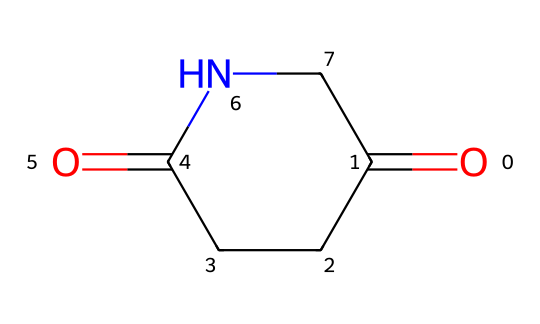What is the total number of carbon atoms in glutarimide? The SMILES representation indicates the presence of three carbon atoms in the cyclic part (C1CCC) and two carbonyl carbon atoms (O=C), totaling five carbon atoms.
Answer: five How many nitrogen atoms are present in the structure of glutarimide? By analyzing the SMILES notation, there is one nitrogen atom (N) in the ring structure of glutarimide.
Answer: one What type of functional group is present in glutarimide? The structure contains both carbonyl groups (C=O) and an amine (N), categorizing it as an imide. An imide is characterized by two carbonyl groups bonded to a nitrogen atom.
Answer: imide What is the ring size of the glutarimide structure? The molecular structure forms a five-membered ring as indicated by the C1CCC(=O)NC1, which includes three carbon atoms and one nitrogen in a ring.
Answer: five-membered How many double bonds are present in glutarimide? The structure contains two double bonds—one each from the two carbonyl groups (O=C) attached to the nitrogen and carbon atoms.
Answer: two What role does the nitrogen atom play in the glutarimide structure? The nitrogen atom functions as a point of connection for the two carbonyl groups, forming the cyclic structure characteristic of imides. This creates unique reactivity often found in antidepressants.
Answer: connection How does the presence of carbonyl groups impact the properties of glutarimide? The carbonyl groups introduce polarization and reactivity, influencing hydrogen bonding and the chemical behavior of glutarimide. This contributes to its pharmacological properties.
Answer: reactivity 